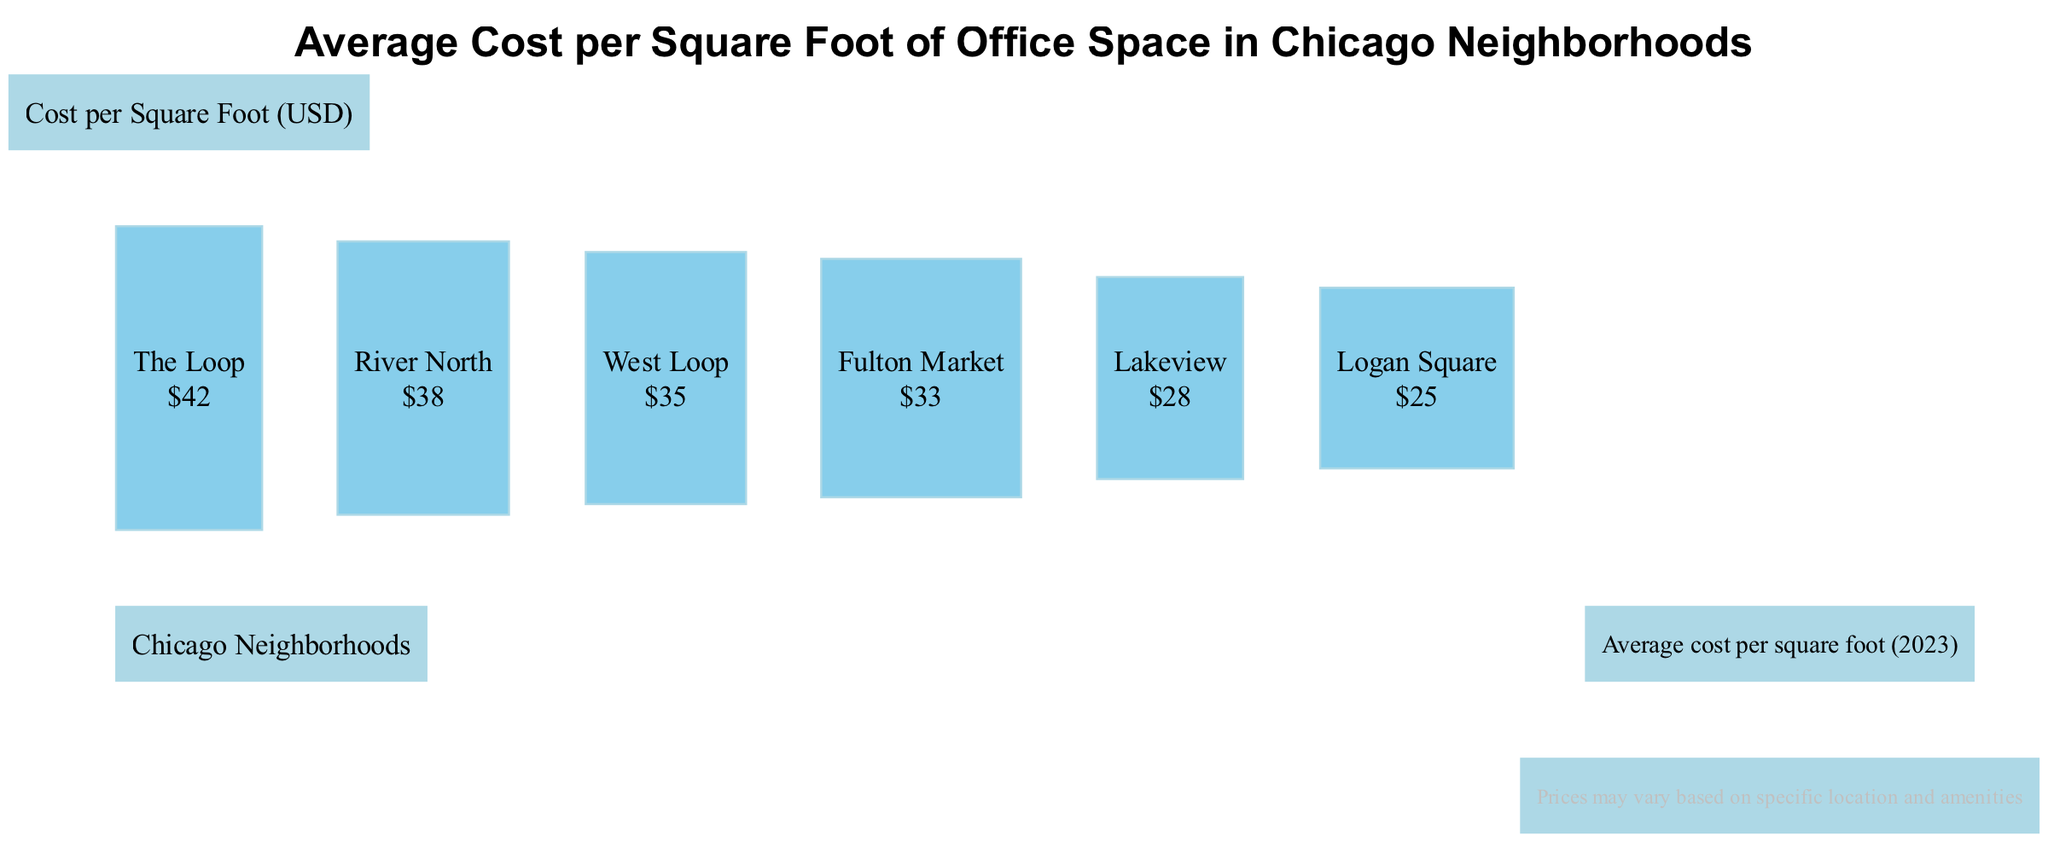What is the average cost per square foot of office space in The Loop? The bar representing The Loop shows a cost labeled as $42, which indicates that this is the average cost per square foot for office space in this neighborhood.
Answer: 42 Which neighborhood has the highest average cost per square foot? By comparing the costs presented on the bars, The Loop has the highest value at $42, making it the neighborhood with the highest average cost per square foot.
Answer: The Loop How many neighborhoods are compared in this diagram? The diagram lists six neighborhoods: The Loop, River North, West Loop, Fulton Market, Lakeview, and Logan Square. Counting each gives a total of six neighborhoods compared in the diagram.
Answer: 6 What is the average cost per square foot for Logan Square? The bar for Logan Square shows the cost of $25, which is its average cost per square foot for office space as depicted in the diagram.
Answer: 25 Which neighborhood has a lower average cost per square foot: Lakeview or Fulton Market? The costs show that Lakeview is $28 and Fulton Market is $33. Since $28 is less than $33, Lakeview has a lower average cost per square foot.
Answer: Lakeview What is the average cost per square foot of office space in River North? The bar for River North indicates a cost of $38, which represents the average cost per square foot in that neighborhood.
Answer: 38 Which two neighborhoods have the closest average cost per square foot? By examining the costs, West Loop at $35 and Fulton Market at $33 have the closest values (only a $2 difference), indicating they are the two neighborhoods with the nearest average costs.
Answer: West Loop and Fulton Market 